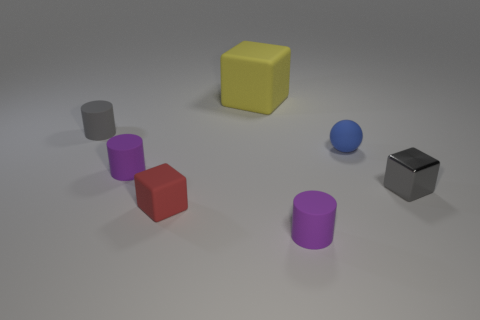Subtract all brown blocks. How many purple cylinders are left? 2 Add 3 blue spheres. How many objects exist? 10 Subtract all cubes. How many objects are left? 4 Add 6 tiny gray blocks. How many tiny gray blocks are left? 7 Add 7 purple cylinders. How many purple cylinders exist? 9 Subtract 0 gray spheres. How many objects are left? 7 Subtract all tiny blocks. Subtract all small blue matte objects. How many objects are left? 4 